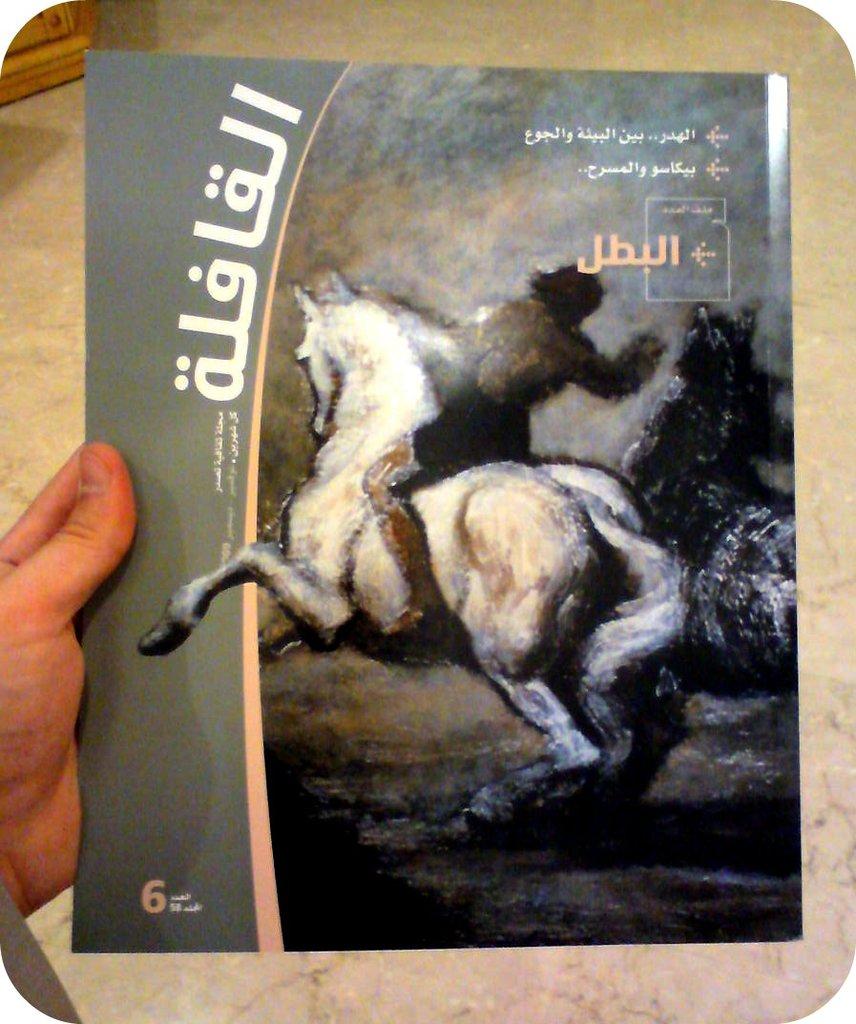Which edition is this book?
Provide a short and direct response. 6. 